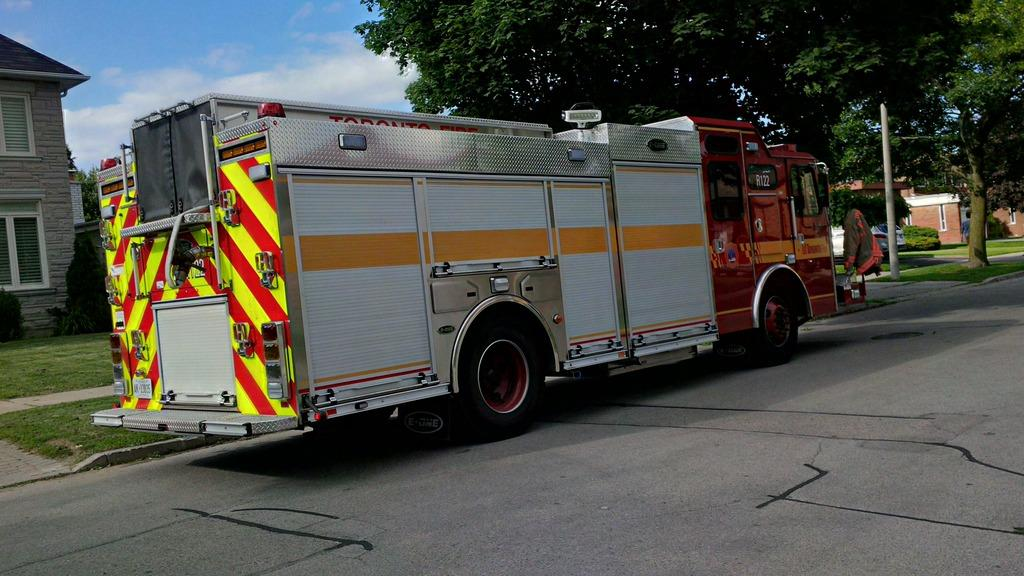What type of vehicle is in the image? There is a fire brigade truck in the image. What is the truck doing in the image? The truck is moving on the road. What can be seen in the background of the image? There are trees visible in the background of the image. What structure is located in the left corner of the image? There is a house in the left corner of the image. What type of skirt is the fire brigade truck wearing in the image? Fire brigade trucks do not wear skirts; they are vehicles. Can you see any bees flying around the fire brigade truck in the image? There is no mention of bees in the image, so it cannot be determined if any are present. 